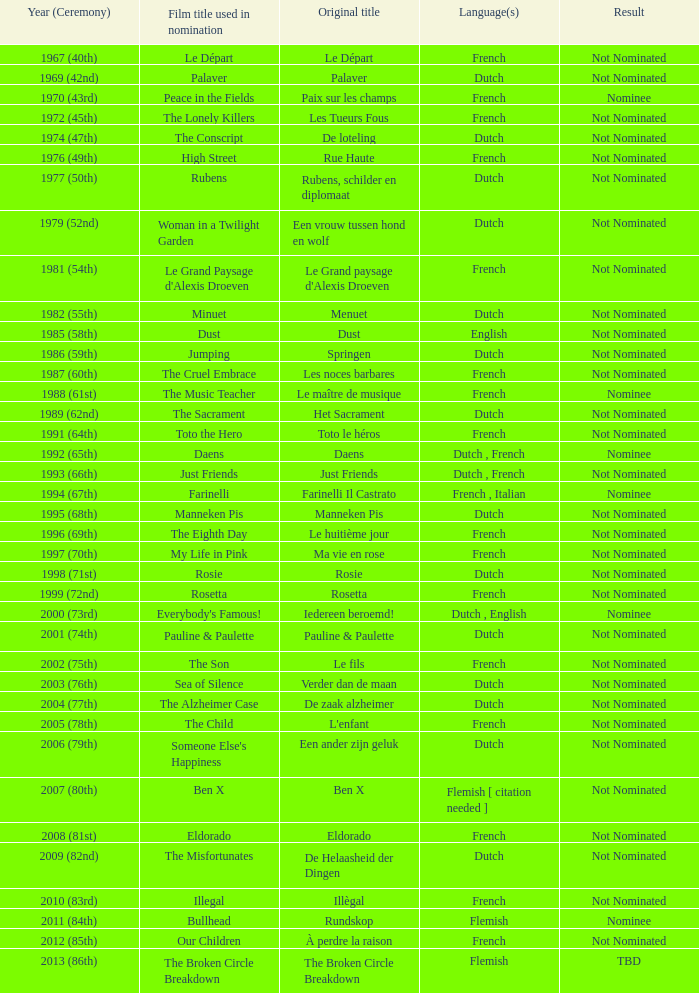In the movie rosie, what language is spoken? Dutch. Could you parse the entire table? {'header': ['Year (Ceremony)', 'Film title used in nomination', 'Original title', 'Language(s)', 'Result'], 'rows': [['1967 (40th)', 'Le Départ', 'Le Départ', 'French', 'Not Nominated'], ['1969 (42nd)', 'Palaver', 'Palaver', 'Dutch', 'Not Nominated'], ['1970 (43rd)', 'Peace in the Fields', 'Paix sur les champs', 'French', 'Nominee'], ['1972 (45th)', 'The Lonely Killers', 'Les Tueurs Fous', 'French', 'Not Nominated'], ['1974 (47th)', 'The Conscript', 'De loteling', 'Dutch', 'Not Nominated'], ['1976 (49th)', 'High Street', 'Rue Haute', 'French', 'Not Nominated'], ['1977 (50th)', 'Rubens', 'Rubens, schilder en diplomaat', 'Dutch', 'Not Nominated'], ['1979 (52nd)', 'Woman in a Twilight Garden', 'Een vrouw tussen hond en wolf', 'Dutch', 'Not Nominated'], ['1981 (54th)', "Le Grand Paysage d'Alexis Droeven", "Le Grand paysage d'Alexis Droeven", 'French', 'Not Nominated'], ['1982 (55th)', 'Minuet', 'Menuet', 'Dutch', 'Not Nominated'], ['1985 (58th)', 'Dust', 'Dust', 'English', 'Not Nominated'], ['1986 (59th)', 'Jumping', 'Springen', 'Dutch', 'Not Nominated'], ['1987 (60th)', 'The Cruel Embrace', 'Les noces barbares', 'French', 'Not Nominated'], ['1988 (61st)', 'The Music Teacher', 'Le maître de musique', 'French', 'Nominee'], ['1989 (62nd)', 'The Sacrament', 'Het Sacrament', 'Dutch', 'Not Nominated'], ['1991 (64th)', 'Toto the Hero', 'Toto le héros', 'French', 'Not Nominated'], ['1992 (65th)', 'Daens', 'Daens', 'Dutch , French', 'Nominee'], ['1993 (66th)', 'Just Friends', 'Just Friends', 'Dutch , French', 'Not Nominated'], ['1994 (67th)', 'Farinelli', 'Farinelli Il Castrato', 'French , Italian', 'Nominee'], ['1995 (68th)', 'Manneken Pis', 'Manneken Pis', 'Dutch', 'Not Nominated'], ['1996 (69th)', 'The Eighth Day', 'Le huitième jour', 'French', 'Not Nominated'], ['1997 (70th)', 'My Life in Pink', 'Ma vie en rose', 'French', 'Not Nominated'], ['1998 (71st)', 'Rosie', 'Rosie', 'Dutch', 'Not Nominated'], ['1999 (72nd)', 'Rosetta', 'Rosetta', 'French', 'Not Nominated'], ['2000 (73rd)', "Everybody's Famous!", 'Iedereen beroemd!', 'Dutch , English', 'Nominee'], ['2001 (74th)', 'Pauline & Paulette', 'Pauline & Paulette', 'Dutch', 'Not Nominated'], ['2002 (75th)', 'The Son', 'Le fils', 'French', 'Not Nominated'], ['2003 (76th)', 'Sea of Silence', 'Verder dan de maan', 'Dutch', 'Not Nominated'], ['2004 (77th)', 'The Alzheimer Case', 'De zaak alzheimer', 'Dutch', 'Not Nominated'], ['2005 (78th)', 'The Child', "L'enfant", 'French', 'Not Nominated'], ['2006 (79th)', "Someone Else's Happiness", 'Een ander zijn geluk', 'Dutch', 'Not Nominated'], ['2007 (80th)', 'Ben X', 'Ben X', 'Flemish [ citation needed ]', 'Not Nominated'], ['2008 (81st)', 'Eldorado', 'Eldorado', 'French', 'Not Nominated'], ['2009 (82nd)', 'The Misfortunates', 'De Helaasheid der Dingen', 'Dutch', 'Not Nominated'], ['2010 (83rd)', 'Illegal', 'Illègal', 'French', 'Not Nominated'], ['2011 (84th)', 'Bullhead', 'Rundskop', 'Flemish', 'Nominee'], ['2012 (85th)', 'Our Children', 'À perdre la raison', 'French', 'Not Nominated'], ['2013 (86th)', 'The Broken Circle Breakdown', 'The Broken Circle Breakdown', 'Flemish', 'TBD']]} 